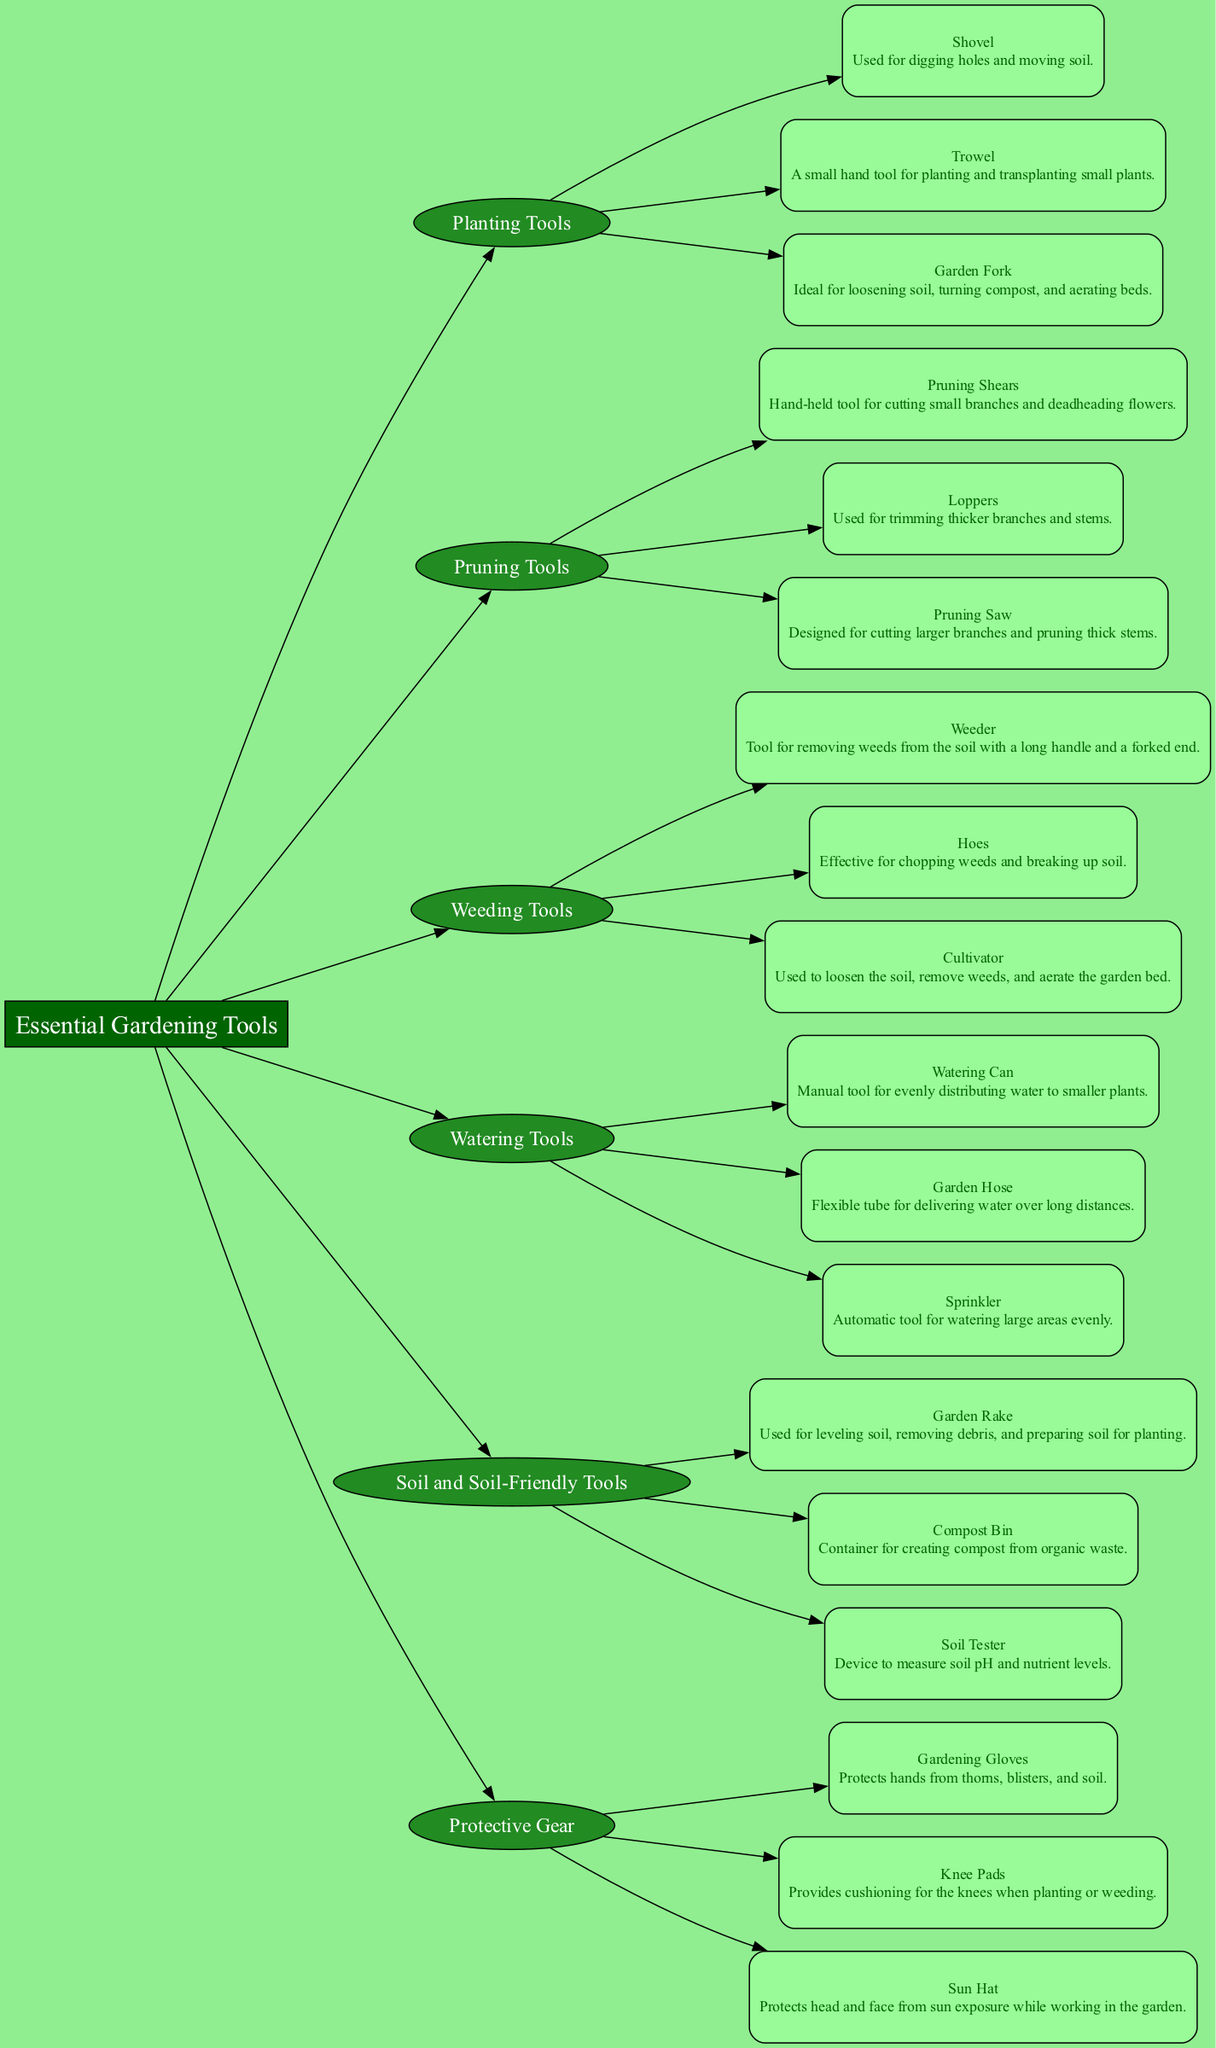What are the main categories of gardening tools illustrated in the diagram? The diagram illustrates the main categories such as Planting Tools, Pruning Tools, Weeding Tools, Watering Tools, Soil and Soil-Friendly Tools, and Protective Gear. These categories are represented as distinct nodes connected to the main node, Essential Gardening Tools.
Answer: Planting Tools, Pruning Tools, Weeding Tools, Watering Tools, Soil and Soil-Friendly Tools, Protective Gear How many tools are listed under the Pruning Tools category? The Pruning Tools category includes three tools: Pruning Shears, Loppers, and Pruning Saw. By counting the nodes under this category, we find that there are three distinct tools represented.
Answer: 3 What type of tool is a Watering Can? A Watering Can is categorized as a manual tool used for evenly distributing water to smaller plants. The description associated with the Watering Can node confirms its function as a tool.
Answer: Manual tool Which tool is specifically designed for cutting larger branches? The Pruning Saw is specifically designed for cutting larger branches and pruning thick stems, as indicated in its description under the Pruning Tools category.
Answer: Pruning Saw What function do Garden Gloves serve according to the diagram? Garden Gloves protect hands from thorns, blisters, and soil. This information is found in the description of the Gardening Gloves node under the Protective Gear category.
Answer: Protects hands Name a tool used for removing weeds from the soil. The Weeder is one of the tools listed under Weeding Tools used for removing weeds from the soil. Its description states its specific purpose, confirming its function.
Answer: Weeder Which tool is ideal for loosening soil and turning compost? The Garden Fork is ideal for loosening soil, turning compost, and aerating beds according to its description under the Planting Tools category. This function distinguishes it from other tools.
Answer: Garden Fork How is a Compost Bin categorized in the diagram? The Compost Bin is categorized under Soil and Soil-Friendly Tools, as shown in the diagram. This categorization indicates its purpose related to soil health and composting.
Answer: Soil and Soil-Friendly Tools 